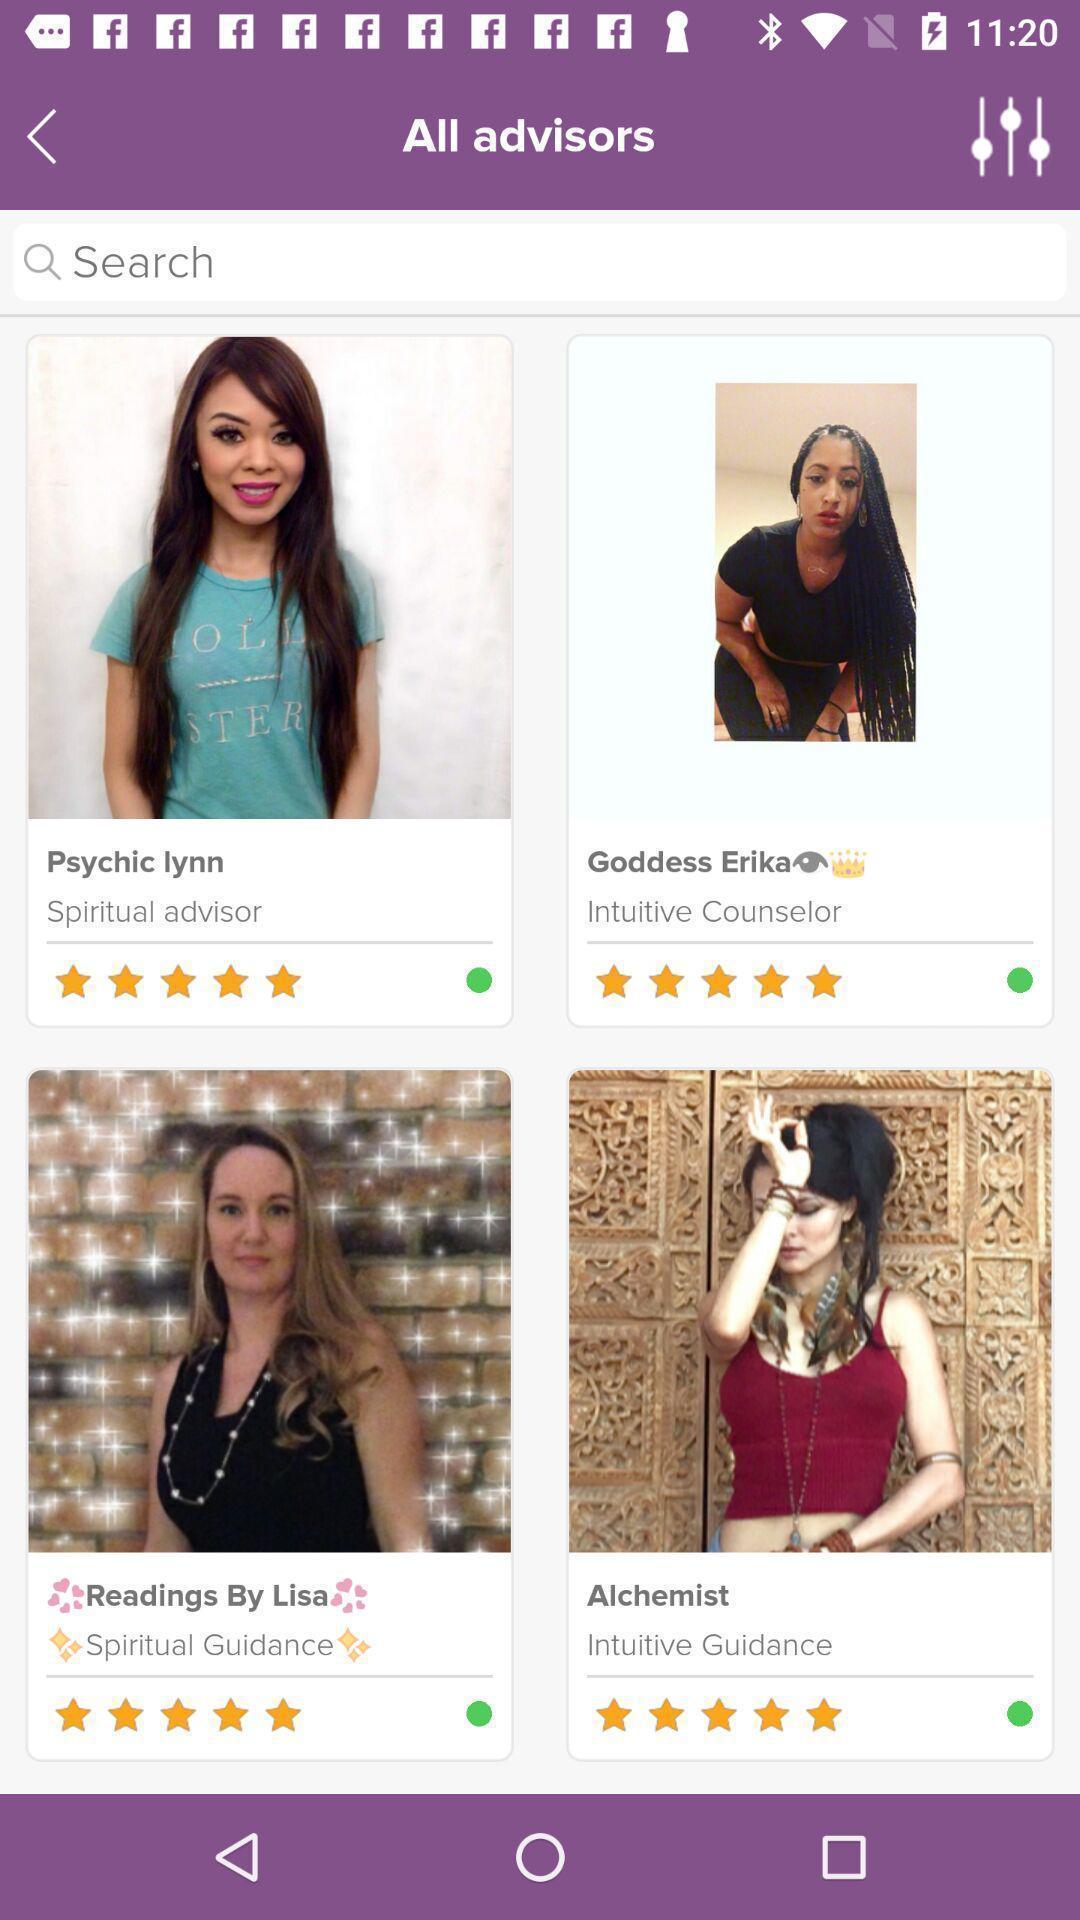Describe the key features of this screenshot. Social app showing list of advisors. 